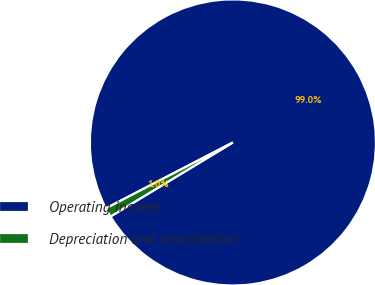<chart> <loc_0><loc_0><loc_500><loc_500><pie_chart><fcel>Operating income<fcel>Depreciation and amortization<nl><fcel>98.96%<fcel>1.04%<nl></chart> 